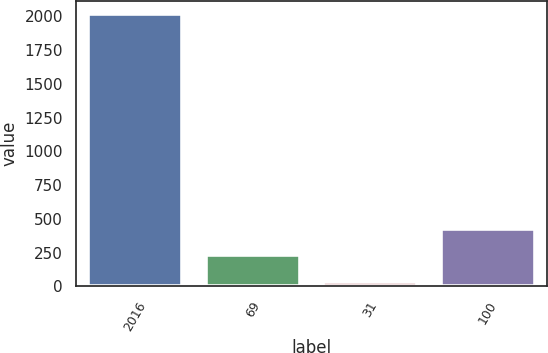Convert chart to OTSL. <chart><loc_0><loc_0><loc_500><loc_500><bar_chart><fcel>2016<fcel>69<fcel>31<fcel>100<nl><fcel>2015<fcel>229.4<fcel>31<fcel>427.8<nl></chart> 